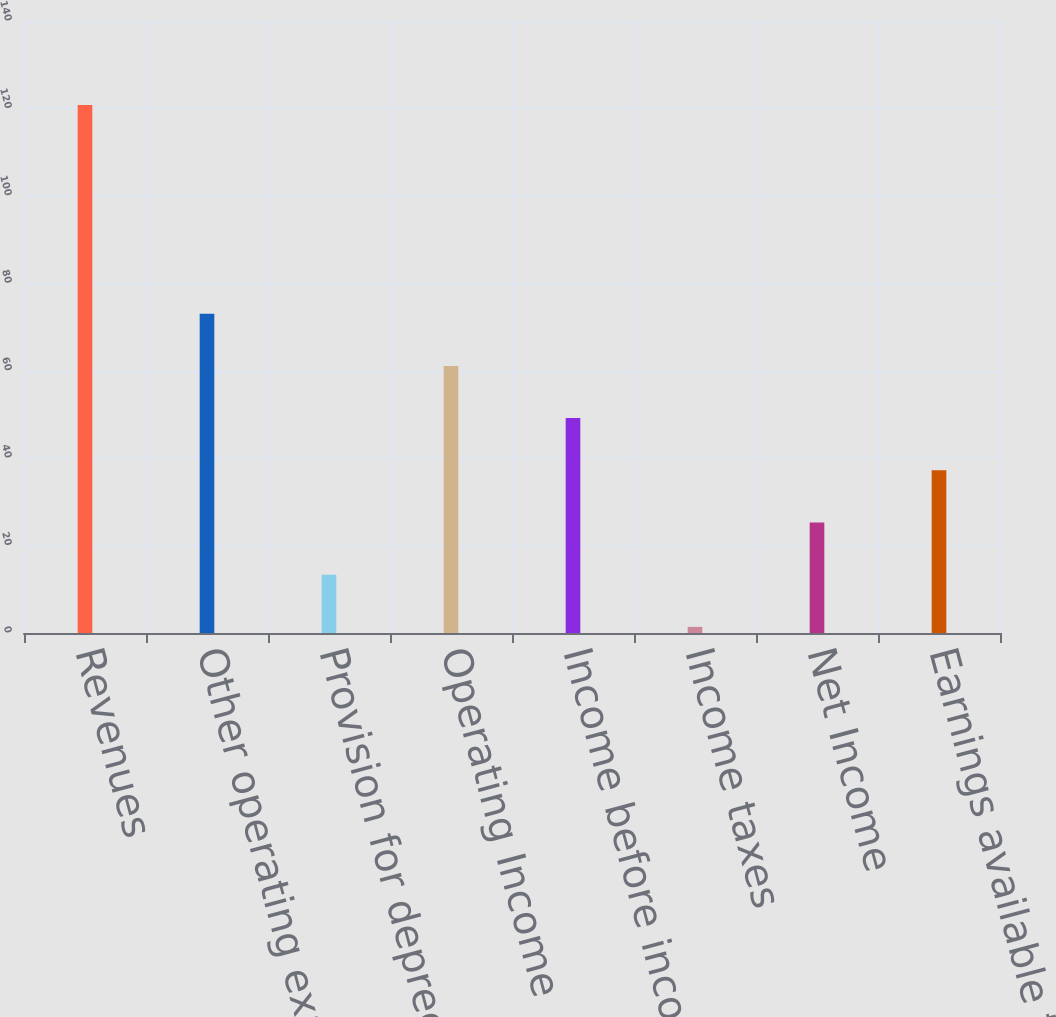<chart> <loc_0><loc_0><loc_500><loc_500><bar_chart><fcel>Revenues<fcel>Other operating expense<fcel>Provision for depreciation<fcel>Operating Income<fcel>Income before income taxes<fcel>Income taxes<fcel>Net Income<fcel>Earnings available to Parent<nl><fcel>120.8<fcel>73.04<fcel>13.34<fcel>61.1<fcel>49.16<fcel>1.4<fcel>25.28<fcel>37.22<nl></chart> 